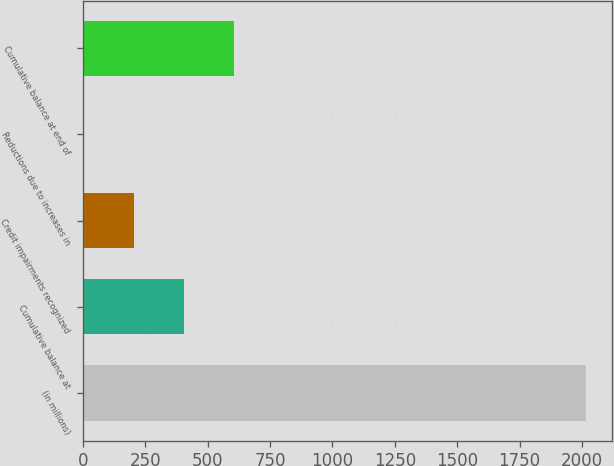Convert chart to OTSL. <chart><loc_0><loc_0><loc_500><loc_500><bar_chart><fcel>(in millions)<fcel>Cumulative balance at<fcel>Credit impairments recognized<fcel>Reductions due to increases in<fcel>Cumulative balance at end of<nl><fcel>2018<fcel>405.2<fcel>203.6<fcel>2<fcel>606.8<nl></chart> 